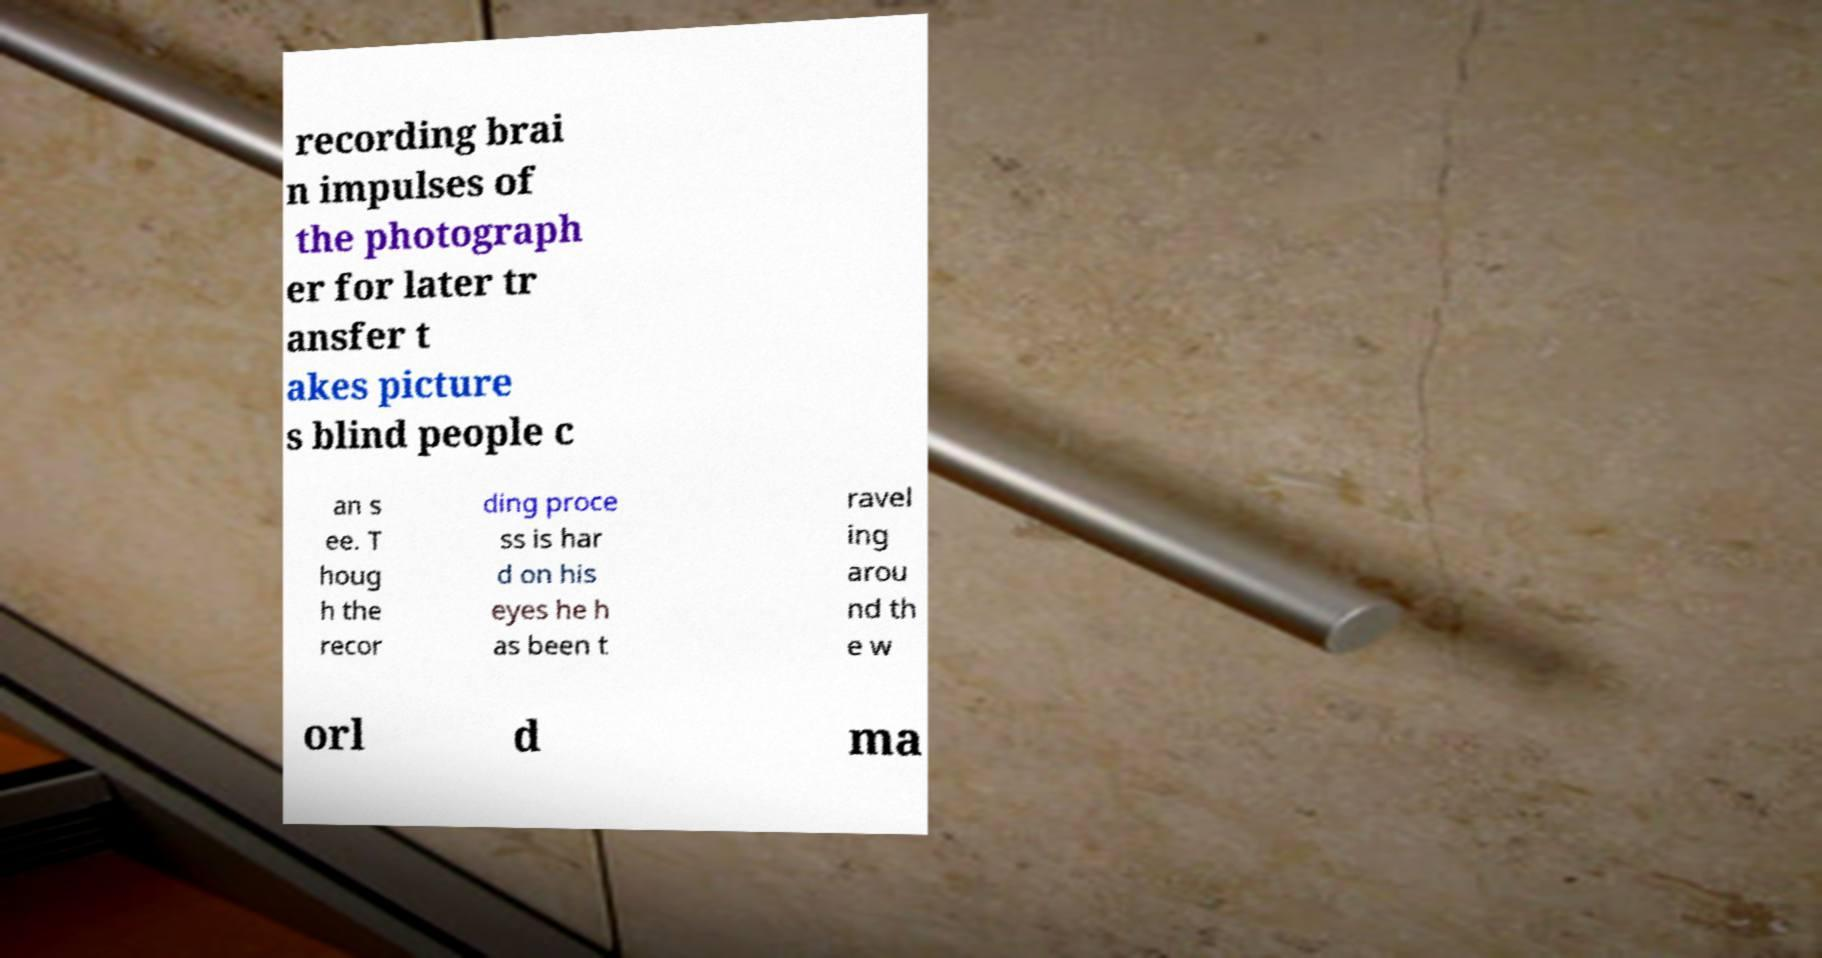Could you extract and type out the text from this image? recording brai n impulses of the photograph er for later tr ansfer t akes picture s blind people c an s ee. T houg h the recor ding proce ss is har d on his eyes he h as been t ravel ing arou nd th e w orl d ma 